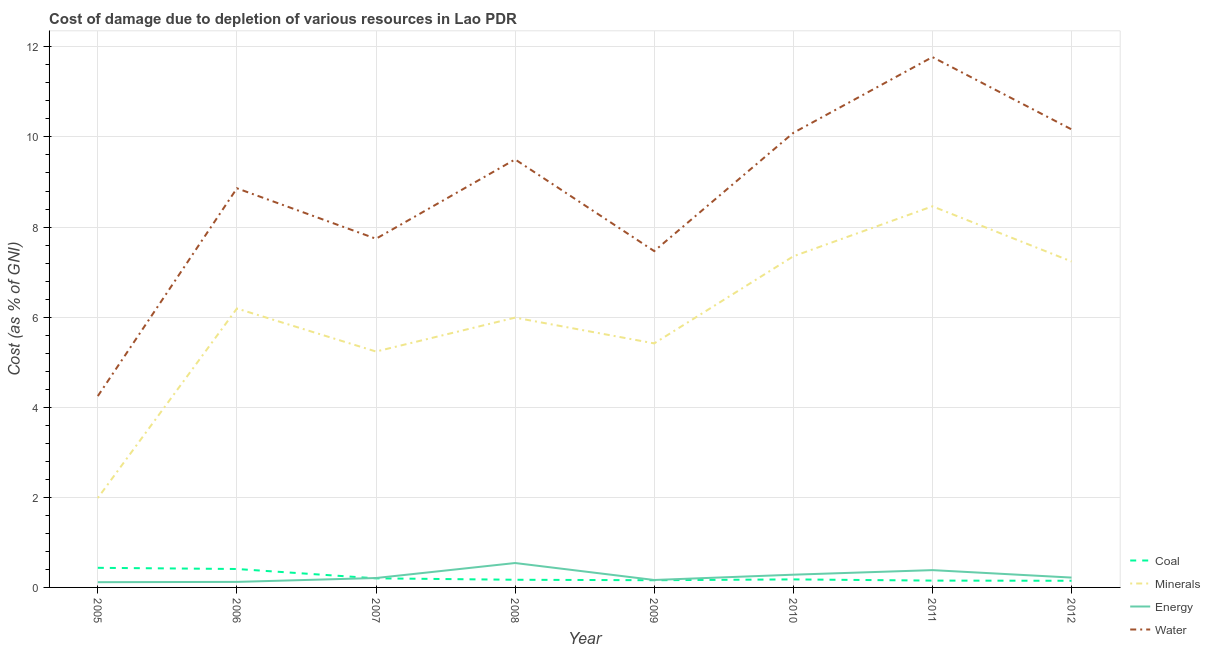Does the line corresponding to cost of damage due to depletion of water intersect with the line corresponding to cost of damage due to depletion of coal?
Your response must be concise. No. Is the number of lines equal to the number of legend labels?
Ensure brevity in your answer.  Yes. What is the cost of damage due to depletion of coal in 2006?
Give a very brief answer. 0.41. Across all years, what is the maximum cost of damage due to depletion of energy?
Your answer should be compact. 0.54. Across all years, what is the minimum cost of damage due to depletion of coal?
Your answer should be compact. 0.15. In which year was the cost of damage due to depletion of minerals minimum?
Your answer should be compact. 2005. What is the total cost of damage due to depletion of energy in the graph?
Make the answer very short. 2.04. What is the difference between the cost of damage due to depletion of minerals in 2005 and that in 2010?
Your answer should be very brief. -5.36. What is the difference between the cost of damage due to depletion of coal in 2009 and the cost of damage due to depletion of minerals in 2010?
Your response must be concise. -7.19. What is the average cost of damage due to depletion of energy per year?
Provide a short and direct response. 0.26. In the year 2006, what is the difference between the cost of damage due to depletion of water and cost of damage due to depletion of energy?
Make the answer very short. 8.74. What is the ratio of the cost of damage due to depletion of water in 2007 to that in 2008?
Provide a succinct answer. 0.81. Is the cost of damage due to depletion of energy in 2008 less than that in 2011?
Offer a terse response. No. Is the difference between the cost of damage due to depletion of energy in 2008 and 2010 greater than the difference between the cost of damage due to depletion of water in 2008 and 2010?
Your answer should be very brief. Yes. What is the difference between the highest and the second highest cost of damage due to depletion of water?
Ensure brevity in your answer.  1.6. What is the difference between the highest and the lowest cost of damage due to depletion of energy?
Provide a short and direct response. 0.43. In how many years, is the cost of damage due to depletion of coal greater than the average cost of damage due to depletion of coal taken over all years?
Offer a very short reply. 2. Is the sum of the cost of damage due to depletion of minerals in 2005 and 2010 greater than the maximum cost of damage due to depletion of coal across all years?
Keep it short and to the point. Yes. Is it the case that in every year, the sum of the cost of damage due to depletion of coal and cost of damage due to depletion of minerals is greater than the cost of damage due to depletion of energy?
Your answer should be compact. Yes. Does the cost of damage due to depletion of water monotonically increase over the years?
Keep it short and to the point. No. Is the cost of damage due to depletion of coal strictly greater than the cost of damage due to depletion of energy over the years?
Offer a very short reply. No. What is the difference between two consecutive major ticks on the Y-axis?
Provide a succinct answer. 2. Does the graph contain any zero values?
Keep it short and to the point. No. Does the graph contain grids?
Provide a succinct answer. Yes. Where does the legend appear in the graph?
Your response must be concise. Bottom right. How many legend labels are there?
Your answer should be very brief. 4. How are the legend labels stacked?
Provide a short and direct response. Vertical. What is the title of the graph?
Make the answer very short. Cost of damage due to depletion of various resources in Lao PDR . Does "Water" appear as one of the legend labels in the graph?
Give a very brief answer. Yes. What is the label or title of the Y-axis?
Keep it short and to the point. Cost (as % of GNI). What is the Cost (as % of GNI) in Coal in 2005?
Give a very brief answer. 0.44. What is the Cost (as % of GNI) in Minerals in 2005?
Provide a short and direct response. 1.99. What is the Cost (as % of GNI) of Energy in 2005?
Provide a succinct answer. 0.12. What is the Cost (as % of GNI) in Water in 2005?
Give a very brief answer. 4.25. What is the Cost (as % of GNI) in Coal in 2006?
Keep it short and to the point. 0.41. What is the Cost (as % of GNI) of Minerals in 2006?
Make the answer very short. 6.19. What is the Cost (as % of GNI) in Energy in 2006?
Ensure brevity in your answer.  0.12. What is the Cost (as % of GNI) in Water in 2006?
Offer a very short reply. 8.86. What is the Cost (as % of GNI) in Coal in 2007?
Your answer should be very brief. 0.2. What is the Cost (as % of GNI) of Minerals in 2007?
Make the answer very short. 5.24. What is the Cost (as % of GNI) in Energy in 2007?
Keep it short and to the point. 0.21. What is the Cost (as % of GNI) of Water in 2007?
Provide a short and direct response. 7.74. What is the Cost (as % of GNI) in Coal in 2008?
Your answer should be compact. 0.17. What is the Cost (as % of GNI) of Minerals in 2008?
Give a very brief answer. 5.99. What is the Cost (as % of GNI) of Energy in 2008?
Your response must be concise. 0.54. What is the Cost (as % of GNI) of Water in 2008?
Offer a very short reply. 9.5. What is the Cost (as % of GNI) in Coal in 2009?
Give a very brief answer. 0.16. What is the Cost (as % of GNI) in Minerals in 2009?
Provide a short and direct response. 5.42. What is the Cost (as % of GNI) of Energy in 2009?
Offer a terse response. 0.17. What is the Cost (as % of GNI) in Water in 2009?
Keep it short and to the point. 7.47. What is the Cost (as % of GNI) of Coal in 2010?
Offer a terse response. 0.18. What is the Cost (as % of GNI) of Minerals in 2010?
Offer a terse response. 7.35. What is the Cost (as % of GNI) of Energy in 2010?
Your answer should be very brief. 0.28. What is the Cost (as % of GNI) in Water in 2010?
Give a very brief answer. 10.09. What is the Cost (as % of GNI) of Coal in 2011?
Offer a very short reply. 0.15. What is the Cost (as % of GNI) of Minerals in 2011?
Offer a terse response. 8.46. What is the Cost (as % of GNI) in Energy in 2011?
Your answer should be compact. 0.38. What is the Cost (as % of GNI) in Water in 2011?
Provide a succinct answer. 11.77. What is the Cost (as % of GNI) of Coal in 2012?
Your answer should be very brief. 0.15. What is the Cost (as % of GNI) of Minerals in 2012?
Your response must be concise. 7.24. What is the Cost (as % of GNI) of Energy in 2012?
Make the answer very short. 0.22. What is the Cost (as % of GNI) of Water in 2012?
Provide a succinct answer. 10.17. Across all years, what is the maximum Cost (as % of GNI) in Coal?
Offer a very short reply. 0.44. Across all years, what is the maximum Cost (as % of GNI) of Minerals?
Your response must be concise. 8.46. Across all years, what is the maximum Cost (as % of GNI) of Energy?
Your answer should be compact. 0.54. Across all years, what is the maximum Cost (as % of GNI) in Water?
Your answer should be very brief. 11.77. Across all years, what is the minimum Cost (as % of GNI) of Coal?
Ensure brevity in your answer.  0.15. Across all years, what is the minimum Cost (as % of GNI) in Minerals?
Your answer should be compact. 1.99. Across all years, what is the minimum Cost (as % of GNI) of Energy?
Your answer should be very brief. 0.12. Across all years, what is the minimum Cost (as % of GNI) of Water?
Your answer should be compact. 4.25. What is the total Cost (as % of GNI) of Coal in the graph?
Keep it short and to the point. 1.85. What is the total Cost (as % of GNI) in Minerals in the graph?
Your answer should be very brief. 47.87. What is the total Cost (as % of GNI) of Energy in the graph?
Offer a terse response. 2.04. What is the total Cost (as % of GNI) of Water in the graph?
Your response must be concise. 69.85. What is the difference between the Cost (as % of GNI) in Coal in 2005 and that in 2006?
Make the answer very short. 0.03. What is the difference between the Cost (as % of GNI) in Minerals in 2005 and that in 2006?
Your answer should be compact. -4.21. What is the difference between the Cost (as % of GNI) of Energy in 2005 and that in 2006?
Your answer should be very brief. -0.01. What is the difference between the Cost (as % of GNI) of Water in 2005 and that in 2006?
Offer a terse response. -4.61. What is the difference between the Cost (as % of GNI) in Coal in 2005 and that in 2007?
Provide a short and direct response. 0.23. What is the difference between the Cost (as % of GNI) of Minerals in 2005 and that in 2007?
Offer a terse response. -3.25. What is the difference between the Cost (as % of GNI) of Energy in 2005 and that in 2007?
Your response must be concise. -0.09. What is the difference between the Cost (as % of GNI) of Water in 2005 and that in 2007?
Your response must be concise. -3.49. What is the difference between the Cost (as % of GNI) of Coal in 2005 and that in 2008?
Offer a very short reply. 0.27. What is the difference between the Cost (as % of GNI) of Minerals in 2005 and that in 2008?
Give a very brief answer. -4. What is the difference between the Cost (as % of GNI) in Energy in 2005 and that in 2008?
Make the answer very short. -0.43. What is the difference between the Cost (as % of GNI) of Water in 2005 and that in 2008?
Your answer should be compact. -5.25. What is the difference between the Cost (as % of GNI) of Coal in 2005 and that in 2009?
Provide a succinct answer. 0.28. What is the difference between the Cost (as % of GNI) of Minerals in 2005 and that in 2009?
Provide a short and direct response. -3.43. What is the difference between the Cost (as % of GNI) in Energy in 2005 and that in 2009?
Keep it short and to the point. -0.05. What is the difference between the Cost (as % of GNI) in Water in 2005 and that in 2009?
Give a very brief answer. -3.22. What is the difference between the Cost (as % of GNI) in Coal in 2005 and that in 2010?
Ensure brevity in your answer.  0.26. What is the difference between the Cost (as % of GNI) of Minerals in 2005 and that in 2010?
Ensure brevity in your answer.  -5.36. What is the difference between the Cost (as % of GNI) in Energy in 2005 and that in 2010?
Your answer should be compact. -0.17. What is the difference between the Cost (as % of GNI) in Water in 2005 and that in 2010?
Your answer should be very brief. -5.84. What is the difference between the Cost (as % of GNI) in Coal in 2005 and that in 2011?
Provide a short and direct response. 0.28. What is the difference between the Cost (as % of GNI) of Minerals in 2005 and that in 2011?
Provide a short and direct response. -6.47. What is the difference between the Cost (as % of GNI) of Energy in 2005 and that in 2011?
Provide a short and direct response. -0.27. What is the difference between the Cost (as % of GNI) in Water in 2005 and that in 2011?
Offer a very short reply. -7.53. What is the difference between the Cost (as % of GNI) in Coal in 2005 and that in 2012?
Provide a succinct answer. 0.29. What is the difference between the Cost (as % of GNI) of Minerals in 2005 and that in 2012?
Ensure brevity in your answer.  -5.25. What is the difference between the Cost (as % of GNI) in Energy in 2005 and that in 2012?
Offer a terse response. -0.1. What is the difference between the Cost (as % of GNI) of Water in 2005 and that in 2012?
Your response must be concise. -5.92. What is the difference between the Cost (as % of GNI) in Coal in 2006 and that in 2007?
Ensure brevity in your answer.  0.21. What is the difference between the Cost (as % of GNI) of Minerals in 2006 and that in 2007?
Give a very brief answer. 0.95. What is the difference between the Cost (as % of GNI) in Energy in 2006 and that in 2007?
Provide a succinct answer. -0.09. What is the difference between the Cost (as % of GNI) in Water in 2006 and that in 2007?
Provide a succinct answer. 1.12. What is the difference between the Cost (as % of GNI) in Coal in 2006 and that in 2008?
Ensure brevity in your answer.  0.24. What is the difference between the Cost (as % of GNI) of Minerals in 2006 and that in 2008?
Provide a short and direct response. 0.2. What is the difference between the Cost (as % of GNI) in Energy in 2006 and that in 2008?
Your answer should be very brief. -0.42. What is the difference between the Cost (as % of GNI) in Water in 2006 and that in 2008?
Your answer should be very brief. -0.64. What is the difference between the Cost (as % of GNI) in Coal in 2006 and that in 2009?
Your answer should be very brief. 0.25. What is the difference between the Cost (as % of GNI) of Minerals in 2006 and that in 2009?
Provide a succinct answer. 0.77. What is the difference between the Cost (as % of GNI) in Energy in 2006 and that in 2009?
Provide a succinct answer. -0.04. What is the difference between the Cost (as % of GNI) in Water in 2006 and that in 2009?
Ensure brevity in your answer.  1.39. What is the difference between the Cost (as % of GNI) in Coal in 2006 and that in 2010?
Your answer should be compact. 0.23. What is the difference between the Cost (as % of GNI) in Minerals in 2006 and that in 2010?
Offer a terse response. -1.16. What is the difference between the Cost (as % of GNI) of Energy in 2006 and that in 2010?
Offer a very short reply. -0.16. What is the difference between the Cost (as % of GNI) in Water in 2006 and that in 2010?
Make the answer very short. -1.23. What is the difference between the Cost (as % of GNI) of Coal in 2006 and that in 2011?
Ensure brevity in your answer.  0.26. What is the difference between the Cost (as % of GNI) in Minerals in 2006 and that in 2011?
Make the answer very short. -2.27. What is the difference between the Cost (as % of GNI) in Energy in 2006 and that in 2011?
Offer a very short reply. -0.26. What is the difference between the Cost (as % of GNI) of Water in 2006 and that in 2011?
Make the answer very short. -2.91. What is the difference between the Cost (as % of GNI) in Coal in 2006 and that in 2012?
Your response must be concise. 0.26. What is the difference between the Cost (as % of GNI) of Minerals in 2006 and that in 2012?
Make the answer very short. -1.04. What is the difference between the Cost (as % of GNI) of Energy in 2006 and that in 2012?
Offer a terse response. -0.1. What is the difference between the Cost (as % of GNI) in Water in 2006 and that in 2012?
Keep it short and to the point. -1.31. What is the difference between the Cost (as % of GNI) in Coal in 2007 and that in 2008?
Make the answer very short. 0.03. What is the difference between the Cost (as % of GNI) of Minerals in 2007 and that in 2008?
Keep it short and to the point. -0.75. What is the difference between the Cost (as % of GNI) of Energy in 2007 and that in 2008?
Offer a very short reply. -0.33. What is the difference between the Cost (as % of GNI) in Water in 2007 and that in 2008?
Provide a short and direct response. -1.76. What is the difference between the Cost (as % of GNI) of Coal in 2007 and that in 2009?
Provide a short and direct response. 0.04. What is the difference between the Cost (as % of GNI) in Minerals in 2007 and that in 2009?
Give a very brief answer. -0.18. What is the difference between the Cost (as % of GNI) in Energy in 2007 and that in 2009?
Your answer should be very brief. 0.04. What is the difference between the Cost (as % of GNI) in Water in 2007 and that in 2009?
Offer a terse response. 0.27. What is the difference between the Cost (as % of GNI) of Coal in 2007 and that in 2010?
Keep it short and to the point. 0.02. What is the difference between the Cost (as % of GNI) in Minerals in 2007 and that in 2010?
Offer a terse response. -2.11. What is the difference between the Cost (as % of GNI) of Energy in 2007 and that in 2010?
Your answer should be very brief. -0.07. What is the difference between the Cost (as % of GNI) of Water in 2007 and that in 2010?
Make the answer very short. -2.35. What is the difference between the Cost (as % of GNI) in Coal in 2007 and that in 2011?
Provide a succinct answer. 0.05. What is the difference between the Cost (as % of GNI) of Minerals in 2007 and that in 2011?
Ensure brevity in your answer.  -3.22. What is the difference between the Cost (as % of GNI) of Energy in 2007 and that in 2011?
Offer a terse response. -0.18. What is the difference between the Cost (as % of GNI) in Water in 2007 and that in 2011?
Keep it short and to the point. -4.03. What is the difference between the Cost (as % of GNI) of Coal in 2007 and that in 2012?
Ensure brevity in your answer.  0.05. What is the difference between the Cost (as % of GNI) in Minerals in 2007 and that in 2012?
Your response must be concise. -2. What is the difference between the Cost (as % of GNI) in Energy in 2007 and that in 2012?
Offer a terse response. -0.01. What is the difference between the Cost (as % of GNI) in Water in 2007 and that in 2012?
Your response must be concise. -2.43. What is the difference between the Cost (as % of GNI) in Coal in 2008 and that in 2009?
Offer a very short reply. 0.01. What is the difference between the Cost (as % of GNI) of Minerals in 2008 and that in 2009?
Offer a very short reply. 0.57. What is the difference between the Cost (as % of GNI) of Energy in 2008 and that in 2009?
Keep it short and to the point. 0.38. What is the difference between the Cost (as % of GNI) of Water in 2008 and that in 2009?
Your response must be concise. 2.04. What is the difference between the Cost (as % of GNI) in Coal in 2008 and that in 2010?
Make the answer very short. -0.01. What is the difference between the Cost (as % of GNI) of Minerals in 2008 and that in 2010?
Ensure brevity in your answer.  -1.36. What is the difference between the Cost (as % of GNI) of Energy in 2008 and that in 2010?
Your response must be concise. 0.26. What is the difference between the Cost (as % of GNI) in Water in 2008 and that in 2010?
Make the answer very short. -0.59. What is the difference between the Cost (as % of GNI) in Coal in 2008 and that in 2011?
Your response must be concise. 0.02. What is the difference between the Cost (as % of GNI) in Minerals in 2008 and that in 2011?
Make the answer very short. -2.47. What is the difference between the Cost (as % of GNI) in Energy in 2008 and that in 2011?
Offer a terse response. 0.16. What is the difference between the Cost (as % of GNI) of Water in 2008 and that in 2011?
Your answer should be compact. -2.27. What is the difference between the Cost (as % of GNI) of Coal in 2008 and that in 2012?
Your answer should be very brief. 0.02. What is the difference between the Cost (as % of GNI) of Minerals in 2008 and that in 2012?
Make the answer very short. -1.25. What is the difference between the Cost (as % of GNI) in Energy in 2008 and that in 2012?
Provide a short and direct response. 0.32. What is the difference between the Cost (as % of GNI) in Water in 2008 and that in 2012?
Offer a terse response. -0.67. What is the difference between the Cost (as % of GNI) in Coal in 2009 and that in 2010?
Offer a terse response. -0.02. What is the difference between the Cost (as % of GNI) of Minerals in 2009 and that in 2010?
Keep it short and to the point. -1.93. What is the difference between the Cost (as % of GNI) of Energy in 2009 and that in 2010?
Your response must be concise. -0.12. What is the difference between the Cost (as % of GNI) in Water in 2009 and that in 2010?
Offer a very short reply. -2.62. What is the difference between the Cost (as % of GNI) in Coal in 2009 and that in 2011?
Give a very brief answer. 0.01. What is the difference between the Cost (as % of GNI) in Minerals in 2009 and that in 2011?
Provide a succinct answer. -3.04. What is the difference between the Cost (as % of GNI) in Energy in 2009 and that in 2011?
Give a very brief answer. -0.22. What is the difference between the Cost (as % of GNI) in Water in 2009 and that in 2011?
Offer a terse response. -4.31. What is the difference between the Cost (as % of GNI) of Coal in 2009 and that in 2012?
Your answer should be very brief. 0.01. What is the difference between the Cost (as % of GNI) of Minerals in 2009 and that in 2012?
Keep it short and to the point. -1.82. What is the difference between the Cost (as % of GNI) of Energy in 2009 and that in 2012?
Give a very brief answer. -0.05. What is the difference between the Cost (as % of GNI) in Water in 2009 and that in 2012?
Your answer should be compact. -2.7. What is the difference between the Cost (as % of GNI) in Coal in 2010 and that in 2011?
Your answer should be compact. 0.03. What is the difference between the Cost (as % of GNI) of Minerals in 2010 and that in 2011?
Keep it short and to the point. -1.11. What is the difference between the Cost (as % of GNI) of Energy in 2010 and that in 2011?
Provide a short and direct response. -0.1. What is the difference between the Cost (as % of GNI) of Water in 2010 and that in 2011?
Provide a succinct answer. -1.68. What is the difference between the Cost (as % of GNI) in Coal in 2010 and that in 2012?
Make the answer very short. 0.03. What is the difference between the Cost (as % of GNI) of Minerals in 2010 and that in 2012?
Your answer should be very brief. 0.11. What is the difference between the Cost (as % of GNI) of Energy in 2010 and that in 2012?
Make the answer very short. 0.06. What is the difference between the Cost (as % of GNI) of Water in 2010 and that in 2012?
Keep it short and to the point. -0.08. What is the difference between the Cost (as % of GNI) in Coal in 2011 and that in 2012?
Your answer should be very brief. 0. What is the difference between the Cost (as % of GNI) of Minerals in 2011 and that in 2012?
Offer a terse response. 1.22. What is the difference between the Cost (as % of GNI) of Energy in 2011 and that in 2012?
Ensure brevity in your answer.  0.17. What is the difference between the Cost (as % of GNI) in Water in 2011 and that in 2012?
Make the answer very short. 1.6. What is the difference between the Cost (as % of GNI) of Coal in 2005 and the Cost (as % of GNI) of Minerals in 2006?
Your response must be concise. -5.76. What is the difference between the Cost (as % of GNI) of Coal in 2005 and the Cost (as % of GNI) of Energy in 2006?
Make the answer very short. 0.31. What is the difference between the Cost (as % of GNI) of Coal in 2005 and the Cost (as % of GNI) of Water in 2006?
Your answer should be compact. -8.43. What is the difference between the Cost (as % of GNI) in Minerals in 2005 and the Cost (as % of GNI) in Energy in 2006?
Give a very brief answer. 1.86. What is the difference between the Cost (as % of GNI) of Minerals in 2005 and the Cost (as % of GNI) of Water in 2006?
Your answer should be compact. -6.88. What is the difference between the Cost (as % of GNI) in Energy in 2005 and the Cost (as % of GNI) in Water in 2006?
Offer a very short reply. -8.74. What is the difference between the Cost (as % of GNI) in Coal in 2005 and the Cost (as % of GNI) in Minerals in 2007?
Your answer should be very brief. -4.8. What is the difference between the Cost (as % of GNI) of Coal in 2005 and the Cost (as % of GNI) of Energy in 2007?
Your answer should be very brief. 0.23. What is the difference between the Cost (as % of GNI) of Coal in 2005 and the Cost (as % of GNI) of Water in 2007?
Provide a succinct answer. -7.3. What is the difference between the Cost (as % of GNI) of Minerals in 2005 and the Cost (as % of GNI) of Energy in 2007?
Offer a terse response. 1.78. What is the difference between the Cost (as % of GNI) in Minerals in 2005 and the Cost (as % of GNI) in Water in 2007?
Offer a very short reply. -5.75. What is the difference between the Cost (as % of GNI) of Energy in 2005 and the Cost (as % of GNI) of Water in 2007?
Your answer should be compact. -7.62. What is the difference between the Cost (as % of GNI) in Coal in 2005 and the Cost (as % of GNI) in Minerals in 2008?
Provide a succinct answer. -5.55. What is the difference between the Cost (as % of GNI) in Coal in 2005 and the Cost (as % of GNI) in Energy in 2008?
Offer a terse response. -0.11. What is the difference between the Cost (as % of GNI) of Coal in 2005 and the Cost (as % of GNI) of Water in 2008?
Ensure brevity in your answer.  -9.07. What is the difference between the Cost (as % of GNI) in Minerals in 2005 and the Cost (as % of GNI) in Energy in 2008?
Keep it short and to the point. 1.44. What is the difference between the Cost (as % of GNI) in Minerals in 2005 and the Cost (as % of GNI) in Water in 2008?
Your answer should be compact. -7.52. What is the difference between the Cost (as % of GNI) in Energy in 2005 and the Cost (as % of GNI) in Water in 2008?
Your answer should be compact. -9.38. What is the difference between the Cost (as % of GNI) of Coal in 2005 and the Cost (as % of GNI) of Minerals in 2009?
Your response must be concise. -4.98. What is the difference between the Cost (as % of GNI) in Coal in 2005 and the Cost (as % of GNI) in Energy in 2009?
Offer a very short reply. 0.27. What is the difference between the Cost (as % of GNI) in Coal in 2005 and the Cost (as % of GNI) in Water in 2009?
Your answer should be very brief. -7.03. What is the difference between the Cost (as % of GNI) in Minerals in 2005 and the Cost (as % of GNI) in Energy in 2009?
Provide a succinct answer. 1.82. What is the difference between the Cost (as % of GNI) in Minerals in 2005 and the Cost (as % of GNI) in Water in 2009?
Provide a succinct answer. -5.48. What is the difference between the Cost (as % of GNI) in Energy in 2005 and the Cost (as % of GNI) in Water in 2009?
Provide a succinct answer. -7.35. What is the difference between the Cost (as % of GNI) in Coal in 2005 and the Cost (as % of GNI) in Minerals in 2010?
Provide a succinct answer. -6.92. What is the difference between the Cost (as % of GNI) in Coal in 2005 and the Cost (as % of GNI) in Energy in 2010?
Make the answer very short. 0.15. What is the difference between the Cost (as % of GNI) in Coal in 2005 and the Cost (as % of GNI) in Water in 2010?
Give a very brief answer. -9.66. What is the difference between the Cost (as % of GNI) of Minerals in 2005 and the Cost (as % of GNI) of Energy in 2010?
Provide a short and direct response. 1.7. What is the difference between the Cost (as % of GNI) of Minerals in 2005 and the Cost (as % of GNI) of Water in 2010?
Offer a very short reply. -8.11. What is the difference between the Cost (as % of GNI) of Energy in 2005 and the Cost (as % of GNI) of Water in 2010?
Provide a short and direct response. -9.97. What is the difference between the Cost (as % of GNI) of Coal in 2005 and the Cost (as % of GNI) of Minerals in 2011?
Your answer should be very brief. -8.03. What is the difference between the Cost (as % of GNI) of Coal in 2005 and the Cost (as % of GNI) of Energy in 2011?
Offer a terse response. 0.05. What is the difference between the Cost (as % of GNI) in Coal in 2005 and the Cost (as % of GNI) in Water in 2011?
Offer a terse response. -11.34. What is the difference between the Cost (as % of GNI) of Minerals in 2005 and the Cost (as % of GNI) of Energy in 2011?
Your answer should be compact. 1.6. What is the difference between the Cost (as % of GNI) of Minerals in 2005 and the Cost (as % of GNI) of Water in 2011?
Offer a terse response. -9.79. What is the difference between the Cost (as % of GNI) in Energy in 2005 and the Cost (as % of GNI) in Water in 2011?
Give a very brief answer. -11.66. What is the difference between the Cost (as % of GNI) in Coal in 2005 and the Cost (as % of GNI) in Minerals in 2012?
Your answer should be very brief. -6.8. What is the difference between the Cost (as % of GNI) in Coal in 2005 and the Cost (as % of GNI) in Energy in 2012?
Keep it short and to the point. 0.22. What is the difference between the Cost (as % of GNI) in Coal in 2005 and the Cost (as % of GNI) in Water in 2012?
Provide a succinct answer. -9.73. What is the difference between the Cost (as % of GNI) of Minerals in 2005 and the Cost (as % of GNI) of Energy in 2012?
Your answer should be very brief. 1.77. What is the difference between the Cost (as % of GNI) of Minerals in 2005 and the Cost (as % of GNI) of Water in 2012?
Provide a succinct answer. -8.18. What is the difference between the Cost (as % of GNI) of Energy in 2005 and the Cost (as % of GNI) of Water in 2012?
Your answer should be very brief. -10.05. What is the difference between the Cost (as % of GNI) in Coal in 2006 and the Cost (as % of GNI) in Minerals in 2007?
Your answer should be very brief. -4.83. What is the difference between the Cost (as % of GNI) of Coal in 2006 and the Cost (as % of GNI) of Energy in 2007?
Your response must be concise. 0.2. What is the difference between the Cost (as % of GNI) in Coal in 2006 and the Cost (as % of GNI) in Water in 2007?
Your response must be concise. -7.33. What is the difference between the Cost (as % of GNI) of Minerals in 2006 and the Cost (as % of GNI) of Energy in 2007?
Keep it short and to the point. 5.98. What is the difference between the Cost (as % of GNI) in Minerals in 2006 and the Cost (as % of GNI) in Water in 2007?
Offer a very short reply. -1.55. What is the difference between the Cost (as % of GNI) in Energy in 2006 and the Cost (as % of GNI) in Water in 2007?
Provide a short and direct response. -7.62. What is the difference between the Cost (as % of GNI) of Coal in 2006 and the Cost (as % of GNI) of Minerals in 2008?
Your response must be concise. -5.58. What is the difference between the Cost (as % of GNI) of Coal in 2006 and the Cost (as % of GNI) of Energy in 2008?
Provide a short and direct response. -0.13. What is the difference between the Cost (as % of GNI) in Coal in 2006 and the Cost (as % of GNI) in Water in 2008?
Offer a terse response. -9.09. What is the difference between the Cost (as % of GNI) in Minerals in 2006 and the Cost (as % of GNI) in Energy in 2008?
Offer a very short reply. 5.65. What is the difference between the Cost (as % of GNI) of Minerals in 2006 and the Cost (as % of GNI) of Water in 2008?
Your answer should be compact. -3.31. What is the difference between the Cost (as % of GNI) of Energy in 2006 and the Cost (as % of GNI) of Water in 2008?
Provide a short and direct response. -9.38. What is the difference between the Cost (as % of GNI) of Coal in 2006 and the Cost (as % of GNI) of Minerals in 2009?
Provide a short and direct response. -5.01. What is the difference between the Cost (as % of GNI) of Coal in 2006 and the Cost (as % of GNI) of Energy in 2009?
Provide a short and direct response. 0.24. What is the difference between the Cost (as % of GNI) in Coal in 2006 and the Cost (as % of GNI) in Water in 2009?
Keep it short and to the point. -7.06. What is the difference between the Cost (as % of GNI) of Minerals in 2006 and the Cost (as % of GNI) of Energy in 2009?
Your response must be concise. 6.03. What is the difference between the Cost (as % of GNI) of Minerals in 2006 and the Cost (as % of GNI) of Water in 2009?
Provide a short and direct response. -1.27. What is the difference between the Cost (as % of GNI) in Energy in 2006 and the Cost (as % of GNI) in Water in 2009?
Ensure brevity in your answer.  -7.34. What is the difference between the Cost (as % of GNI) of Coal in 2006 and the Cost (as % of GNI) of Minerals in 2010?
Keep it short and to the point. -6.94. What is the difference between the Cost (as % of GNI) of Coal in 2006 and the Cost (as % of GNI) of Energy in 2010?
Your answer should be compact. 0.13. What is the difference between the Cost (as % of GNI) in Coal in 2006 and the Cost (as % of GNI) in Water in 2010?
Your answer should be compact. -9.68. What is the difference between the Cost (as % of GNI) in Minerals in 2006 and the Cost (as % of GNI) in Energy in 2010?
Your answer should be compact. 5.91. What is the difference between the Cost (as % of GNI) in Minerals in 2006 and the Cost (as % of GNI) in Water in 2010?
Your response must be concise. -3.9. What is the difference between the Cost (as % of GNI) in Energy in 2006 and the Cost (as % of GNI) in Water in 2010?
Offer a very short reply. -9.97. What is the difference between the Cost (as % of GNI) of Coal in 2006 and the Cost (as % of GNI) of Minerals in 2011?
Make the answer very short. -8.05. What is the difference between the Cost (as % of GNI) of Coal in 2006 and the Cost (as % of GNI) of Energy in 2011?
Your answer should be very brief. 0.03. What is the difference between the Cost (as % of GNI) in Coal in 2006 and the Cost (as % of GNI) in Water in 2011?
Provide a succinct answer. -11.36. What is the difference between the Cost (as % of GNI) of Minerals in 2006 and the Cost (as % of GNI) of Energy in 2011?
Ensure brevity in your answer.  5.81. What is the difference between the Cost (as % of GNI) in Minerals in 2006 and the Cost (as % of GNI) in Water in 2011?
Provide a short and direct response. -5.58. What is the difference between the Cost (as % of GNI) in Energy in 2006 and the Cost (as % of GNI) in Water in 2011?
Your response must be concise. -11.65. What is the difference between the Cost (as % of GNI) of Coal in 2006 and the Cost (as % of GNI) of Minerals in 2012?
Provide a short and direct response. -6.83. What is the difference between the Cost (as % of GNI) of Coal in 2006 and the Cost (as % of GNI) of Energy in 2012?
Provide a succinct answer. 0.19. What is the difference between the Cost (as % of GNI) of Coal in 2006 and the Cost (as % of GNI) of Water in 2012?
Your answer should be very brief. -9.76. What is the difference between the Cost (as % of GNI) in Minerals in 2006 and the Cost (as % of GNI) in Energy in 2012?
Your answer should be very brief. 5.97. What is the difference between the Cost (as % of GNI) of Minerals in 2006 and the Cost (as % of GNI) of Water in 2012?
Make the answer very short. -3.98. What is the difference between the Cost (as % of GNI) of Energy in 2006 and the Cost (as % of GNI) of Water in 2012?
Your response must be concise. -10.05. What is the difference between the Cost (as % of GNI) of Coal in 2007 and the Cost (as % of GNI) of Minerals in 2008?
Provide a short and direct response. -5.79. What is the difference between the Cost (as % of GNI) in Coal in 2007 and the Cost (as % of GNI) in Energy in 2008?
Offer a very short reply. -0.34. What is the difference between the Cost (as % of GNI) in Coal in 2007 and the Cost (as % of GNI) in Water in 2008?
Your answer should be very brief. -9.3. What is the difference between the Cost (as % of GNI) of Minerals in 2007 and the Cost (as % of GNI) of Energy in 2008?
Offer a terse response. 4.69. What is the difference between the Cost (as % of GNI) of Minerals in 2007 and the Cost (as % of GNI) of Water in 2008?
Offer a very short reply. -4.26. What is the difference between the Cost (as % of GNI) in Energy in 2007 and the Cost (as % of GNI) in Water in 2008?
Your answer should be very brief. -9.29. What is the difference between the Cost (as % of GNI) of Coal in 2007 and the Cost (as % of GNI) of Minerals in 2009?
Offer a very short reply. -5.22. What is the difference between the Cost (as % of GNI) in Coal in 2007 and the Cost (as % of GNI) in Energy in 2009?
Ensure brevity in your answer.  0.04. What is the difference between the Cost (as % of GNI) of Coal in 2007 and the Cost (as % of GNI) of Water in 2009?
Your response must be concise. -7.26. What is the difference between the Cost (as % of GNI) in Minerals in 2007 and the Cost (as % of GNI) in Energy in 2009?
Your response must be concise. 5.07. What is the difference between the Cost (as % of GNI) of Minerals in 2007 and the Cost (as % of GNI) of Water in 2009?
Give a very brief answer. -2.23. What is the difference between the Cost (as % of GNI) in Energy in 2007 and the Cost (as % of GNI) in Water in 2009?
Your answer should be compact. -7.26. What is the difference between the Cost (as % of GNI) of Coal in 2007 and the Cost (as % of GNI) of Minerals in 2010?
Offer a terse response. -7.15. What is the difference between the Cost (as % of GNI) of Coal in 2007 and the Cost (as % of GNI) of Energy in 2010?
Ensure brevity in your answer.  -0.08. What is the difference between the Cost (as % of GNI) of Coal in 2007 and the Cost (as % of GNI) of Water in 2010?
Offer a very short reply. -9.89. What is the difference between the Cost (as % of GNI) of Minerals in 2007 and the Cost (as % of GNI) of Energy in 2010?
Your response must be concise. 4.95. What is the difference between the Cost (as % of GNI) in Minerals in 2007 and the Cost (as % of GNI) in Water in 2010?
Keep it short and to the point. -4.85. What is the difference between the Cost (as % of GNI) of Energy in 2007 and the Cost (as % of GNI) of Water in 2010?
Your answer should be very brief. -9.88. What is the difference between the Cost (as % of GNI) of Coal in 2007 and the Cost (as % of GNI) of Minerals in 2011?
Your answer should be compact. -8.26. What is the difference between the Cost (as % of GNI) in Coal in 2007 and the Cost (as % of GNI) in Energy in 2011?
Provide a succinct answer. -0.18. What is the difference between the Cost (as % of GNI) of Coal in 2007 and the Cost (as % of GNI) of Water in 2011?
Your answer should be very brief. -11.57. What is the difference between the Cost (as % of GNI) in Minerals in 2007 and the Cost (as % of GNI) in Energy in 2011?
Keep it short and to the point. 4.85. What is the difference between the Cost (as % of GNI) in Minerals in 2007 and the Cost (as % of GNI) in Water in 2011?
Your answer should be very brief. -6.54. What is the difference between the Cost (as % of GNI) of Energy in 2007 and the Cost (as % of GNI) of Water in 2011?
Provide a succinct answer. -11.56. What is the difference between the Cost (as % of GNI) of Coal in 2007 and the Cost (as % of GNI) of Minerals in 2012?
Offer a very short reply. -7.03. What is the difference between the Cost (as % of GNI) in Coal in 2007 and the Cost (as % of GNI) in Energy in 2012?
Your answer should be very brief. -0.02. What is the difference between the Cost (as % of GNI) of Coal in 2007 and the Cost (as % of GNI) of Water in 2012?
Offer a terse response. -9.97. What is the difference between the Cost (as % of GNI) in Minerals in 2007 and the Cost (as % of GNI) in Energy in 2012?
Give a very brief answer. 5.02. What is the difference between the Cost (as % of GNI) of Minerals in 2007 and the Cost (as % of GNI) of Water in 2012?
Provide a short and direct response. -4.93. What is the difference between the Cost (as % of GNI) of Energy in 2007 and the Cost (as % of GNI) of Water in 2012?
Provide a succinct answer. -9.96. What is the difference between the Cost (as % of GNI) of Coal in 2008 and the Cost (as % of GNI) of Minerals in 2009?
Keep it short and to the point. -5.25. What is the difference between the Cost (as % of GNI) in Coal in 2008 and the Cost (as % of GNI) in Energy in 2009?
Your response must be concise. 0.01. What is the difference between the Cost (as % of GNI) of Coal in 2008 and the Cost (as % of GNI) of Water in 2009?
Keep it short and to the point. -7.3. What is the difference between the Cost (as % of GNI) of Minerals in 2008 and the Cost (as % of GNI) of Energy in 2009?
Keep it short and to the point. 5.82. What is the difference between the Cost (as % of GNI) in Minerals in 2008 and the Cost (as % of GNI) in Water in 2009?
Offer a very short reply. -1.48. What is the difference between the Cost (as % of GNI) of Energy in 2008 and the Cost (as % of GNI) of Water in 2009?
Ensure brevity in your answer.  -6.92. What is the difference between the Cost (as % of GNI) of Coal in 2008 and the Cost (as % of GNI) of Minerals in 2010?
Your answer should be compact. -7.18. What is the difference between the Cost (as % of GNI) of Coal in 2008 and the Cost (as % of GNI) of Energy in 2010?
Provide a short and direct response. -0.11. What is the difference between the Cost (as % of GNI) of Coal in 2008 and the Cost (as % of GNI) of Water in 2010?
Keep it short and to the point. -9.92. What is the difference between the Cost (as % of GNI) of Minerals in 2008 and the Cost (as % of GNI) of Energy in 2010?
Make the answer very short. 5.71. What is the difference between the Cost (as % of GNI) in Minerals in 2008 and the Cost (as % of GNI) in Water in 2010?
Keep it short and to the point. -4.1. What is the difference between the Cost (as % of GNI) in Energy in 2008 and the Cost (as % of GNI) in Water in 2010?
Give a very brief answer. -9.55. What is the difference between the Cost (as % of GNI) of Coal in 2008 and the Cost (as % of GNI) of Minerals in 2011?
Your response must be concise. -8.29. What is the difference between the Cost (as % of GNI) of Coal in 2008 and the Cost (as % of GNI) of Energy in 2011?
Provide a short and direct response. -0.21. What is the difference between the Cost (as % of GNI) of Coal in 2008 and the Cost (as % of GNI) of Water in 2011?
Ensure brevity in your answer.  -11.6. What is the difference between the Cost (as % of GNI) in Minerals in 2008 and the Cost (as % of GNI) in Energy in 2011?
Keep it short and to the point. 5.61. What is the difference between the Cost (as % of GNI) in Minerals in 2008 and the Cost (as % of GNI) in Water in 2011?
Your answer should be compact. -5.78. What is the difference between the Cost (as % of GNI) of Energy in 2008 and the Cost (as % of GNI) of Water in 2011?
Offer a terse response. -11.23. What is the difference between the Cost (as % of GNI) in Coal in 2008 and the Cost (as % of GNI) in Minerals in 2012?
Provide a succinct answer. -7.07. What is the difference between the Cost (as % of GNI) of Coal in 2008 and the Cost (as % of GNI) of Energy in 2012?
Ensure brevity in your answer.  -0.05. What is the difference between the Cost (as % of GNI) in Coal in 2008 and the Cost (as % of GNI) in Water in 2012?
Offer a terse response. -10. What is the difference between the Cost (as % of GNI) in Minerals in 2008 and the Cost (as % of GNI) in Energy in 2012?
Your answer should be very brief. 5.77. What is the difference between the Cost (as % of GNI) of Minerals in 2008 and the Cost (as % of GNI) of Water in 2012?
Offer a very short reply. -4.18. What is the difference between the Cost (as % of GNI) of Energy in 2008 and the Cost (as % of GNI) of Water in 2012?
Provide a short and direct response. -9.63. What is the difference between the Cost (as % of GNI) in Coal in 2009 and the Cost (as % of GNI) in Minerals in 2010?
Your answer should be compact. -7.19. What is the difference between the Cost (as % of GNI) in Coal in 2009 and the Cost (as % of GNI) in Energy in 2010?
Give a very brief answer. -0.12. What is the difference between the Cost (as % of GNI) of Coal in 2009 and the Cost (as % of GNI) of Water in 2010?
Your response must be concise. -9.93. What is the difference between the Cost (as % of GNI) of Minerals in 2009 and the Cost (as % of GNI) of Energy in 2010?
Keep it short and to the point. 5.13. What is the difference between the Cost (as % of GNI) in Minerals in 2009 and the Cost (as % of GNI) in Water in 2010?
Your answer should be very brief. -4.67. What is the difference between the Cost (as % of GNI) in Energy in 2009 and the Cost (as % of GNI) in Water in 2010?
Offer a very short reply. -9.93. What is the difference between the Cost (as % of GNI) in Coal in 2009 and the Cost (as % of GNI) in Minerals in 2011?
Your answer should be very brief. -8.3. What is the difference between the Cost (as % of GNI) in Coal in 2009 and the Cost (as % of GNI) in Energy in 2011?
Your answer should be compact. -0.22. What is the difference between the Cost (as % of GNI) in Coal in 2009 and the Cost (as % of GNI) in Water in 2011?
Your answer should be compact. -11.61. What is the difference between the Cost (as % of GNI) in Minerals in 2009 and the Cost (as % of GNI) in Energy in 2011?
Ensure brevity in your answer.  5.03. What is the difference between the Cost (as % of GNI) in Minerals in 2009 and the Cost (as % of GNI) in Water in 2011?
Your answer should be very brief. -6.36. What is the difference between the Cost (as % of GNI) in Energy in 2009 and the Cost (as % of GNI) in Water in 2011?
Keep it short and to the point. -11.61. What is the difference between the Cost (as % of GNI) of Coal in 2009 and the Cost (as % of GNI) of Minerals in 2012?
Provide a short and direct response. -7.08. What is the difference between the Cost (as % of GNI) in Coal in 2009 and the Cost (as % of GNI) in Energy in 2012?
Provide a short and direct response. -0.06. What is the difference between the Cost (as % of GNI) in Coal in 2009 and the Cost (as % of GNI) in Water in 2012?
Your response must be concise. -10.01. What is the difference between the Cost (as % of GNI) of Minerals in 2009 and the Cost (as % of GNI) of Energy in 2012?
Give a very brief answer. 5.2. What is the difference between the Cost (as % of GNI) of Minerals in 2009 and the Cost (as % of GNI) of Water in 2012?
Ensure brevity in your answer.  -4.75. What is the difference between the Cost (as % of GNI) of Energy in 2009 and the Cost (as % of GNI) of Water in 2012?
Make the answer very short. -10. What is the difference between the Cost (as % of GNI) of Coal in 2010 and the Cost (as % of GNI) of Minerals in 2011?
Give a very brief answer. -8.28. What is the difference between the Cost (as % of GNI) of Coal in 2010 and the Cost (as % of GNI) of Energy in 2011?
Offer a terse response. -0.21. What is the difference between the Cost (as % of GNI) in Coal in 2010 and the Cost (as % of GNI) in Water in 2011?
Your response must be concise. -11.6. What is the difference between the Cost (as % of GNI) of Minerals in 2010 and the Cost (as % of GNI) of Energy in 2011?
Keep it short and to the point. 6.97. What is the difference between the Cost (as % of GNI) of Minerals in 2010 and the Cost (as % of GNI) of Water in 2011?
Offer a terse response. -4.42. What is the difference between the Cost (as % of GNI) of Energy in 2010 and the Cost (as % of GNI) of Water in 2011?
Offer a very short reply. -11.49. What is the difference between the Cost (as % of GNI) in Coal in 2010 and the Cost (as % of GNI) in Minerals in 2012?
Offer a very short reply. -7.06. What is the difference between the Cost (as % of GNI) in Coal in 2010 and the Cost (as % of GNI) in Energy in 2012?
Keep it short and to the point. -0.04. What is the difference between the Cost (as % of GNI) of Coal in 2010 and the Cost (as % of GNI) of Water in 2012?
Provide a short and direct response. -9.99. What is the difference between the Cost (as % of GNI) of Minerals in 2010 and the Cost (as % of GNI) of Energy in 2012?
Provide a short and direct response. 7.13. What is the difference between the Cost (as % of GNI) in Minerals in 2010 and the Cost (as % of GNI) in Water in 2012?
Your answer should be compact. -2.82. What is the difference between the Cost (as % of GNI) of Energy in 2010 and the Cost (as % of GNI) of Water in 2012?
Keep it short and to the point. -9.89. What is the difference between the Cost (as % of GNI) of Coal in 2011 and the Cost (as % of GNI) of Minerals in 2012?
Offer a terse response. -7.08. What is the difference between the Cost (as % of GNI) in Coal in 2011 and the Cost (as % of GNI) in Energy in 2012?
Your answer should be very brief. -0.07. What is the difference between the Cost (as % of GNI) in Coal in 2011 and the Cost (as % of GNI) in Water in 2012?
Your answer should be very brief. -10.02. What is the difference between the Cost (as % of GNI) in Minerals in 2011 and the Cost (as % of GNI) in Energy in 2012?
Your answer should be compact. 8.24. What is the difference between the Cost (as % of GNI) of Minerals in 2011 and the Cost (as % of GNI) of Water in 2012?
Offer a very short reply. -1.71. What is the difference between the Cost (as % of GNI) of Energy in 2011 and the Cost (as % of GNI) of Water in 2012?
Keep it short and to the point. -9.78. What is the average Cost (as % of GNI) in Coal per year?
Your response must be concise. 0.23. What is the average Cost (as % of GNI) of Minerals per year?
Offer a terse response. 5.98. What is the average Cost (as % of GNI) of Energy per year?
Keep it short and to the point. 0.26. What is the average Cost (as % of GNI) in Water per year?
Provide a succinct answer. 8.73. In the year 2005, what is the difference between the Cost (as % of GNI) of Coal and Cost (as % of GNI) of Minerals?
Offer a very short reply. -1.55. In the year 2005, what is the difference between the Cost (as % of GNI) in Coal and Cost (as % of GNI) in Energy?
Provide a short and direct response. 0.32. In the year 2005, what is the difference between the Cost (as % of GNI) in Coal and Cost (as % of GNI) in Water?
Keep it short and to the point. -3.81. In the year 2005, what is the difference between the Cost (as % of GNI) of Minerals and Cost (as % of GNI) of Energy?
Offer a very short reply. 1.87. In the year 2005, what is the difference between the Cost (as % of GNI) in Minerals and Cost (as % of GNI) in Water?
Your response must be concise. -2.26. In the year 2005, what is the difference between the Cost (as % of GNI) in Energy and Cost (as % of GNI) in Water?
Provide a succinct answer. -4.13. In the year 2006, what is the difference between the Cost (as % of GNI) of Coal and Cost (as % of GNI) of Minerals?
Your answer should be very brief. -5.78. In the year 2006, what is the difference between the Cost (as % of GNI) of Coal and Cost (as % of GNI) of Energy?
Offer a terse response. 0.29. In the year 2006, what is the difference between the Cost (as % of GNI) in Coal and Cost (as % of GNI) in Water?
Give a very brief answer. -8.45. In the year 2006, what is the difference between the Cost (as % of GNI) in Minerals and Cost (as % of GNI) in Energy?
Offer a terse response. 6.07. In the year 2006, what is the difference between the Cost (as % of GNI) of Minerals and Cost (as % of GNI) of Water?
Provide a short and direct response. -2.67. In the year 2006, what is the difference between the Cost (as % of GNI) of Energy and Cost (as % of GNI) of Water?
Your answer should be compact. -8.74. In the year 2007, what is the difference between the Cost (as % of GNI) in Coal and Cost (as % of GNI) in Minerals?
Make the answer very short. -5.03. In the year 2007, what is the difference between the Cost (as % of GNI) of Coal and Cost (as % of GNI) of Energy?
Offer a terse response. -0.01. In the year 2007, what is the difference between the Cost (as % of GNI) of Coal and Cost (as % of GNI) of Water?
Your answer should be compact. -7.54. In the year 2007, what is the difference between the Cost (as % of GNI) in Minerals and Cost (as % of GNI) in Energy?
Provide a short and direct response. 5.03. In the year 2007, what is the difference between the Cost (as % of GNI) of Minerals and Cost (as % of GNI) of Water?
Provide a succinct answer. -2.5. In the year 2007, what is the difference between the Cost (as % of GNI) in Energy and Cost (as % of GNI) in Water?
Provide a short and direct response. -7.53. In the year 2008, what is the difference between the Cost (as % of GNI) in Coal and Cost (as % of GNI) in Minerals?
Your answer should be very brief. -5.82. In the year 2008, what is the difference between the Cost (as % of GNI) in Coal and Cost (as % of GNI) in Energy?
Offer a terse response. -0.37. In the year 2008, what is the difference between the Cost (as % of GNI) in Coal and Cost (as % of GNI) in Water?
Give a very brief answer. -9.33. In the year 2008, what is the difference between the Cost (as % of GNI) of Minerals and Cost (as % of GNI) of Energy?
Ensure brevity in your answer.  5.45. In the year 2008, what is the difference between the Cost (as % of GNI) of Minerals and Cost (as % of GNI) of Water?
Provide a short and direct response. -3.51. In the year 2008, what is the difference between the Cost (as % of GNI) in Energy and Cost (as % of GNI) in Water?
Your answer should be compact. -8.96. In the year 2009, what is the difference between the Cost (as % of GNI) in Coal and Cost (as % of GNI) in Minerals?
Keep it short and to the point. -5.26. In the year 2009, what is the difference between the Cost (as % of GNI) in Coal and Cost (as % of GNI) in Energy?
Make the answer very short. -0.01. In the year 2009, what is the difference between the Cost (as % of GNI) in Coal and Cost (as % of GNI) in Water?
Give a very brief answer. -7.31. In the year 2009, what is the difference between the Cost (as % of GNI) in Minerals and Cost (as % of GNI) in Energy?
Offer a very short reply. 5.25. In the year 2009, what is the difference between the Cost (as % of GNI) of Minerals and Cost (as % of GNI) of Water?
Provide a succinct answer. -2.05. In the year 2009, what is the difference between the Cost (as % of GNI) of Energy and Cost (as % of GNI) of Water?
Provide a short and direct response. -7.3. In the year 2010, what is the difference between the Cost (as % of GNI) of Coal and Cost (as % of GNI) of Minerals?
Offer a terse response. -7.17. In the year 2010, what is the difference between the Cost (as % of GNI) of Coal and Cost (as % of GNI) of Energy?
Ensure brevity in your answer.  -0.1. In the year 2010, what is the difference between the Cost (as % of GNI) of Coal and Cost (as % of GNI) of Water?
Make the answer very short. -9.91. In the year 2010, what is the difference between the Cost (as % of GNI) of Minerals and Cost (as % of GNI) of Energy?
Offer a terse response. 7.07. In the year 2010, what is the difference between the Cost (as % of GNI) in Minerals and Cost (as % of GNI) in Water?
Provide a succinct answer. -2.74. In the year 2010, what is the difference between the Cost (as % of GNI) of Energy and Cost (as % of GNI) of Water?
Offer a terse response. -9.81. In the year 2011, what is the difference between the Cost (as % of GNI) of Coal and Cost (as % of GNI) of Minerals?
Your answer should be very brief. -8.31. In the year 2011, what is the difference between the Cost (as % of GNI) in Coal and Cost (as % of GNI) in Energy?
Provide a succinct answer. -0.23. In the year 2011, what is the difference between the Cost (as % of GNI) in Coal and Cost (as % of GNI) in Water?
Your answer should be very brief. -11.62. In the year 2011, what is the difference between the Cost (as % of GNI) of Minerals and Cost (as % of GNI) of Energy?
Offer a very short reply. 8.08. In the year 2011, what is the difference between the Cost (as % of GNI) in Minerals and Cost (as % of GNI) in Water?
Offer a very short reply. -3.31. In the year 2011, what is the difference between the Cost (as % of GNI) of Energy and Cost (as % of GNI) of Water?
Your response must be concise. -11.39. In the year 2012, what is the difference between the Cost (as % of GNI) in Coal and Cost (as % of GNI) in Minerals?
Ensure brevity in your answer.  -7.09. In the year 2012, what is the difference between the Cost (as % of GNI) in Coal and Cost (as % of GNI) in Energy?
Your answer should be very brief. -0.07. In the year 2012, what is the difference between the Cost (as % of GNI) of Coal and Cost (as % of GNI) of Water?
Offer a very short reply. -10.02. In the year 2012, what is the difference between the Cost (as % of GNI) in Minerals and Cost (as % of GNI) in Energy?
Ensure brevity in your answer.  7.02. In the year 2012, what is the difference between the Cost (as % of GNI) of Minerals and Cost (as % of GNI) of Water?
Offer a very short reply. -2.93. In the year 2012, what is the difference between the Cost (as % of GNI) in Energy and Cost (as % of GNI) in Water?
Give a very brief answer. -9.95. What is the ratio of the Cost (as % of GNI) in Coal in 2005 to that in 2006?
Your response must be concise. 1.06. What is the ratio of the Cost (as % of GNI) of Minerals in 2005 to that in 2006?
Give a very brief answer. 0.32. What is the ratio of the Cost (as % of GNI) in Energy in 2005 to that in 2006?
Your response must be concise. 0.95. What is the ratio of the Cost (as % of GNI) in Water in 2005 to that in 2006?
Ensure brevity in your answer.  0.48. What is the ratio of the Cost (as % of GNI) in Coal in 2005 to that in 2007?
Ensure brevity in your answer.  2.16. What is the ratio of the Cost (as % of GNI) of Minerals in 2005 to that in 2007?
Provide a succinct answer. 0.38. What is the ratio of the Cost (as % of GNI) in Energy in 2005 to that in 2007?
Your answer should be very brief. 0.56. What is the ratio of the Cost (as % of GNI) of Water in 2005 to that in 2007?
Your answer should be compact. 0.55. What is the ratio of the Cost (as % of GNI) of Coal in 2005 to that in 2008?
Your response must be concise. 2.56. What is the ratio of the Cost (as % of GNI) in Minerals in 2005 to that in 2008?
Give a very brief answer. 0.33. What is the ratio of the Cost (as % of GNI) of Energy in 2005 to that in 2008?
Offer a terse response. 0.21. What is the ratio of the Cost (as % of GNI) in Water in 2005 to that in 2008?
Offer a very short reply. 0.45. What is the ratio of the Cost (as % of GNI) in Coal in 2005 to that in 2009?
Provide a succinct answer. 2.72. What is the ratio of the Cost (as % of GNI) of Minerals in 2005 to that in 2009?
Provide a succinct answer. 0.37. What is the ratio of the Cost (as % of GNI) in Energy in 2005 to that in 2009?
Offer a very short reply. 0.7. What is the ratio of the Cost (as % of GNI) of Water in 2005 to that in 2009?
Offer a terse response. 0.57. What is the ratio of the Cost (as % of GNI) of Coal in 2005 to that in 2010?
Provide a short and direct response. 2.44. What is the ratio of the Cost (as % of GNI) in Minerals in 2005 to that in 2010?
Offer a terse response. 0.27. What is the ratio of the Cost (as % of GNI) in Energy in 2005 to that in 2010?
Provide a succinct answer. 0.41. What is the ratio of the Cost (as % of GNI) of Water in 2005 to that in 2010?
Provide a short and direct response. 0.42. What is the ratio of the Cost (as % of GNI) in Coal in 2005 to that in 2011?
Your answer should be very brief. 2.87. What is the ratio of the Cost (as % of GNI) in Minerals in 2005 to that in 2011?
Ensure brevity in your answer.  0.23. What is the ratio of the Cost (as % of GNI) in Energy in 2005 to that in 2011?
Offer a terse response. 0.3. What is the ratio of the Cost (as % of GNI) in Water in 2005 to that in 2011?
Offer a terse response. 0.36. What is the ratio of the Cost (as % of GNI) of Coal in 2005 to that in 2012?
Make the answer very short. 2.94. What is the ratio of the Cost (as % of GNI) in Minerals in 2005 to that in 2012?
Ensure brevity in your answer.  0.27. What is the ratio of the Cost (as % of GNI) of Energy in 2005 to that in 2012?
Ensure brevity in your answer.  0.53. What is the ratio of the Cost (as % of GNI) in Water in 2005 to that in 2012?
Offer a terse response. 0.42. What is the ratio of the Cost (as % of GNI) of Coal in 2006 to that in 2007?
Make the answer very short. 2.03. What is the ratio of the Cost (as % of GNI) of Minerals in 2006 to that in 2007?
Offer a very short reply. 1.18. What is the ratio of the Cost (as % of GNI) in Energy in 2006 to that in 2007?
Offer a terse response. 0.59. What is the ratio of the Cost (as % of GNI) in Water in 2006 to that in 2007?
Offer a terse response. 1.14. What is the ratio of the Cost (as % of GNI) of Coal in 2006 to that in 2008?
Make the answer very short. 2.4. What is the ratio of the Cost (as % of GNI) in Minerals in 2006 to that in 2008?
Offer a very short reply. 1.03. What is the ratio of the Cost (as % of GNI) in Energy in 2006 to that in 2008?
Your response must be concise. 0.23. What is the ratio of the Cost (as % of GNI) of Water in 2006 to that in 2008?
Your answer should be very brief. 0.93. What is the ratio of the Cost (as % of GNI) of Coal in 2006 to that in 2009?
Provide a succinct answer. 2.56. What is the ratio of the Cost (as % of GNI) of Energy in 2006 to that in 2009?
Offer a terse response. 0.74. What is the ratio of the Cost (as % of GNI) of Water in 2006 to that in 2009?
Your response must be concise. 1.19. What is the ratio of the Cost (as % of GNI) of Coal in 2006 to that in 2010?
Ensure brevity in your answer.  2.3. What is the ratio of the Cost (as % of GNI) of Minerals in 2006 to that in 2010?
Give a very brief answer. 0.84. What is the ratio of the Cost (as % of GNI) of Energy in 2006 to that in 2010?
Keep it short and to the point. 0.43. What is the ratio of the Cost (as % of GNI) of Water in 2006 to that in 2010?
Provide a short and direct response. 0.88. What is the ratio of the Cost (as % of GNI) of Coal in 2006 to that in 2011?
Provide a short and direct response. 2.7. What is the ratio of the Cost (as % of GNI) in Minerals in 2006 to that in 2011?
Keep it short and to the point. 0.73. What is the ratio of the Cost (as % of GNI) of Energy in 2006 to that in 2011?
Make the answer very short. 0.32. What is the ratio of the Cost (as % of GNI) of Water in 2006 to that in 2011?
Ensure brevity in your answer.  0.75. What is the ratio of the Cost (as % of GNI) of Coal in 2006 to that in 2012?
Offer a terse response. 2.76. What is the ratio of the Cost (as % of GNI) in Minerals in 2006 to that in 2012?
Provide a succinct answer. 0.86. What is the ratio of the Cost (as % of GNI) of Energy in 2006 to that in 2012?
Offer a very short reply. 0.56. What is the ratio of the Cost (as % of GNI) of Water in 2006 to that in 2012?
Keep it short and to the point. 0.87. What is the ratio of the Cost (as % of GNI) of Coal in 2007 to that in 2008?
Give a very brief answer. 1.18. What is the ratio of the Cost (as % of GNI) in Minerals in 2007 to that in 2008?
Provide a succinct answer. 0.87. What is the ratio of the Cost (as % of GNI) in Energy in 2007 to that in 2008?
Provide a short and direct response. 0.39. What is the ratio of the Cost (as % of GNI) of Water in 2007 to that in 2008?
Provide a succinct answer. 0.81. What is the ratio of the Cost (as % of GNI) of Coal in 2007 to that in 2009?
Provide a succinct answer. 1.26. What is the ratio of the Cost (as % of GNI) in Minerals in 2007 to that in 2009?
Give a very brief answer. 0.97. What is the ratio of the Cost (as % of GNI) in Energy in 2007 to that in 2009?
Provide a succinct answer. 1.26. What is the ratio of the Cost (as % of GNI) of Water in 2007 to that in 2009?
Keep it short and to the point. 1.04. What is the ratio of the Cost (as % of GNI) in Coal in 2007 to that in 2010?
Ensure brevity in your answer.  1.13. What is the ratio of the Cost (as % of GNI) of Minerals in 2007 to that in 2010?
Your answer should be very brief. 0.71. What is the ratio of the Cost (as % of GNI) of Energy in 2007 to that in 2010?
Provide a short and direct response. 0.74. What is the ratio of the Cost (as % of GNI) in Water in 2007 to that in 2010?
Your answer should be very brief. 0.77. What is the ratio of the Cost (as % of GNI) in Coal in 2007 to that in 2011?
Your answer should be very brief. 1.33. What is the ratio of the Cost (as % of GNI) of Minerals in 2007 to that in 2011?
Make the answer very short. 0.62. What is the ratio of the Cost (as % of GNI) in Energy in 2007 to that in 2011?
Your answer should be compact. 0.54. What is the ratio of the Cost (as % of GNI) of Water in 2007 to that in 2011?
Make the answer very short. 0.66. What is the ratio of the Cost (as % of GNI) of Coal in 2007 to that in 2012?
Provide a succinct answer. 1.36. What is the ratio of the Cost (as % of GNI) of Minerals in 2007 to that in 2012?
Offer a very short reply. 0.72. What is the ratio of the Cost (as % of GNI) of Energy in 2007 to that in 2012?
Make the answer very short. 0.95. What is the ratio of the Cost (as % of GNI) in Water in 2007 to that in 2012?
Provide a short and direct response. 0.76. What is the ratio of the Cost (as % of GNI) of Coal in 2008 to that in 2009?
Provide a short and direct response. 1.06. What is the ratio of the Cost (as % of GNI) in Minerals in 2008 to that in 2009?
Provide a short and direct response. 1.11. What is the ratio of the Cost (as % of GNI) in Energy in 2008 to that in 2009?
Give a very brief answer. 3.28. What is the ratio of the Cost (as % of GNI) in Water in 2008 to that in 2009?
Provide a succinct answer. 1.27. What is the ratio of the Cost (as % of GNI) in Coal in 2008 to that in 2010?
Offer a terse response. 0.96. What is the ratio of the Cost (as % of GNI) of Minerals in 2008 to that in 2010?
Make the answer very short. 0.81. What is the ratio of the Cost (as % of GNI) in Energy in 2008 to that in 2010?
Offer a terse response. 1.92. What is the ratio of the Cost (as % of GNI) of Water in 2008 to that in 2010?
Offer a very short reply. 0.94. What is the ratio of the Cost (as % of GNI) in Coal in 2008 to that in 2011?
Keep it short and to the point. 1.12. What is the ratio of the Cost (as % of GNI) of Minerals in 2008 to that in 2011?
Provide a succinct answer. 0.71. What is the ratio of the Cost (as % of GNI) of Energy in 2008 to that in 2011?
Keep it short and to the point. 1.41. What is the ratio of the Cost (as % of GNI) of Water in 2008 to that in 2011?
Make the answer very short. 0.81. What is the ratio of the Cost (as % of GNI) in Coal in 2008 to that in 2012?
Provide a short and direct response. 1.15. What is the ratio of the Cost (as % of GNI) in Minerals in 2008 to that in 2012?
Make the answer very short. 0.83. What is the ratio of the Cost (as % of GNI) in Energy in 2008 to that in 2012?
Give a very brief answer. 2.48. What is the ratio of the Cost (as % of GNI) of Water in 2008 to that in 2012?
Offer a terse response. 0.93. What is the ratio of the Cost (as % of GNI) in Coal in 2009 to that in 2010?
Provide a succinct answer. 0.9. What is the ratio of the Cost (as % of GNI) in Minerals in 2009 to that in 2010?
Your answer should be compact. 0.74. What is the ratio of the Cost (as % of GNI) in Energy in 2009 to that in 2010?
Give a very brief answer. 0.58. What is the ratio of the Cost (as % of GNI) in Water in 2009 to that in 2010?
Offer a very short reply. 0.74. What is the ratio of the Cost (as % of GNI) of Coal in 2009 to that in 2011?
Your response must be concise. 1.05. What is the ratio of the Cost (as % of GNI) in Minerals in 2009 to that in 2011?
Offer a very short reply. 0.64. What is the ratio of the Cost (as % of GNI) in Energy in 2009 to that in 2011?
Your answer should be compact. 0.43. What is the ratio of the Cost (as % of GNI) in Water in 2009 to that in 2011?
Keep it short and to the point. 0.63. What is the ratio of the Cost (as % of GNI) in Coal in 2009 to that in 2012?
Give a very brief answer. 1.08. What is the ratio of the Cost (as % of GNI) in Minerals in 2009 to that in 2012?
Ensure brevity in your answer.  0.75. What is the ratio of the Cost (as % of GNI) in Energy in 2009 to that in 2012?
Your response must be concise. 0.76. What is the ratio of the Cost (as % of GNI) in Water in 2009 to that in 2012?
Keep it short and to the point. 0.73. What is the ratio of the Cost (as % of GNI) in Coal in 2010 to that in 2011?
Keep it short and to the point. 1.18. What is the ratio of the Cost (as % of GNI) in Minerals in 2010 to that in 2011?
Your answer should be compact. 0.87. What is the ratio of the Cost (as % of GNI) in Energy in 2010 to that in 2011?
Offer a terse response. 0.74. What is the ratio of the Cost (as % of GNI) of Water in 2010 to that in 2011?
Provide a short and direct response. 0.86. What is the ratio of the Cost (as % of GNI) in Coal in 2010 to that in 2012?
Keep it short and to the point. 1.2. What is the ratio of the Cost (as % of GNI) of Minerals in 2010 to that in 2012?
Ensure brevity in your answer.  1.02. What is the ratio of the Cost (as % of GNI) of Energy in 2010 to that in 2012?
Your answer should be compact. 1.29. What is the ratio of the Cost (as % of GNI) in Water in 2010 to that in 2012?
Offer a very short reply. 0.99. What is the ratio of the Cost (as % of GNI) in Coal in 2011 to that in 2012?
Offer a terse response. 1.02. What is the ratio of the Cost (as % of GNI) in Minerals in 2011 to that in 2012?
Give a very brief answer. 1.17. What is the ratio of the Cost (as % of GNI) in Energy in 2011 to that in 2012?
Make the answer very short. 1.76. What is the ratio of the Cost (as % of GNI) in Water in 2011 to that in 2012?
Provide a succinct answer. 1.16. What is the difference between the highest and the second highest Cost (as % of GNI) of Coal?
Make the answer very short. 0.03. What is the difference between the highest and the second highest Cost (as % of GNI) of Minerals?
Provide a succinct answer. 1.11. What is the difference between the highest and the second highest Cost (as % of GNI) in Energy?
Ensure brevity in your answer.  0.16. What is the difference between the highest and the second highest Cost (as % of GNI) of Water?
Offer a terse response. 1.6. What is the difference between the highest and the lowest Cost (as % of GNI) of Coal?
Give a very brief answer. 0.29. What is the difference between the highest and the lowest Cost (as % of GNI) of Minerals?
Offer a terse response. 6.47. What is the difference between the highest and the lowest Cost (as % of GNI) of Energy?
Give a very brief answer. 0.43. What is the difference between the highest and the lowest Cost (as % of GNI) of Water?
Provide a succinct answer. 7.53. 